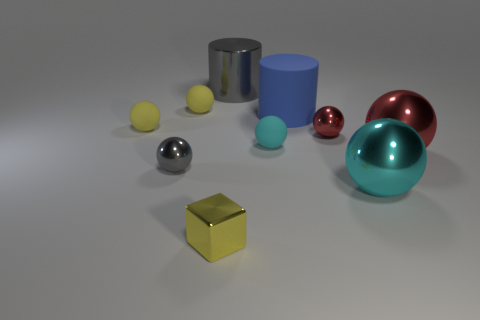What number of metal balls have the same size as the blue matte cylinder?
Provide a succinct answer. 2. There is a yellow matte ball that is to the right of the gray sphere; does it have the same size as the matte object right of the tiny cyan rubber sphere?
Your answer should be very brief. No. Is the number of tiny metal things that are behind the tiny cyan sphere greater than the number of red objects behind the large matte cylinder?
Provide a short and direct response. Yes. How many red metallic things are the same shape as the small cyan rubber thing?
Offer a very short reply. 2. There is a cyan thing that is the same size as the shiny cube; what is it made of?
Provide a short and direct response. Rubber. Are there any cyan objects made of the same material as the big red ball?
Your answer should be compact. Yes. Are there fewer yellow metallic things right of the yellow block than red shiny balls?
Your answer should be compact. Yes. The gray thing behind the cylinder that is to the right of the tiny cyan matte thing is made of what material?
Your answer should be compact. Metal. There is a small shiny object that is behind the cyan metal ball and on the left side of the blue matte cylinder; what shape is it?
Your answer should be compact. Sphere. What number of other things are the same color as the small block?
Your answer should be very brief. 2. 